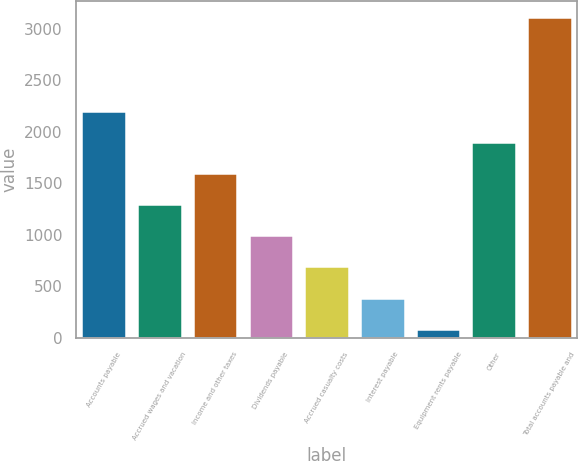Convert chart. <chart><loc_0><loc_0><loc_500><loc_500><bar_chart><fcel>Accounts payable<fcel>Accrued wages and vacation<fcel>Income and other taxes<fcel>Dividends payable<fcel>Accrued casualty costs<fcel>Interest payable<fcel>Equipment rents payable<fcel>Other<fcel>Total accounts payable and<nl><fcel>2202.6<fcel>1297.2<fcel>1599<fcel>995.4<fcel>693.6<fcel>391.8<fcel>90<fcel>1900.8<fcel>3108<nl></chart> 